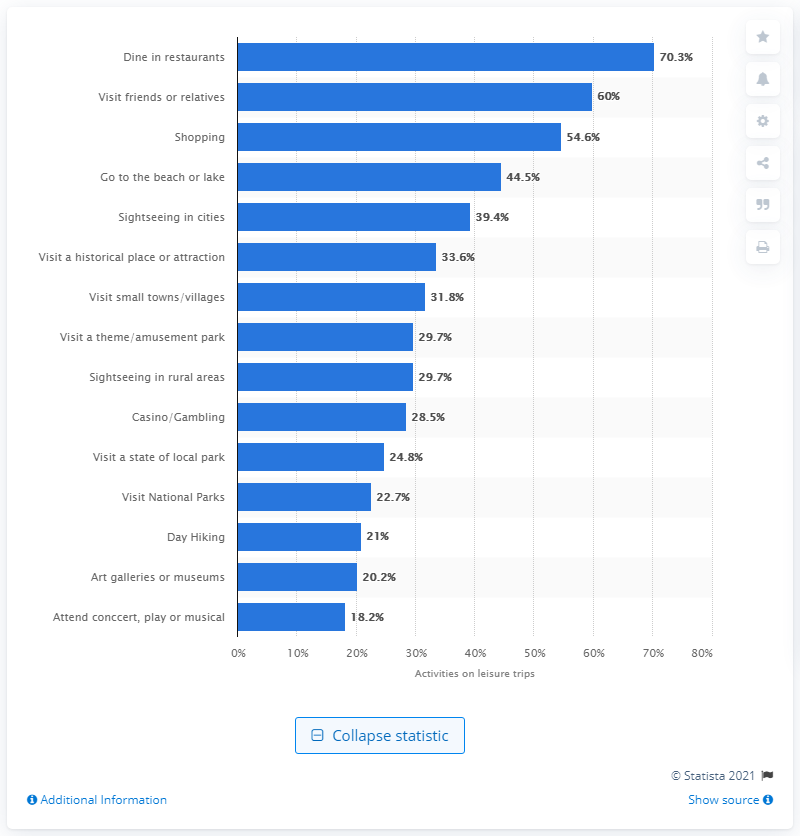What percentage of leisure trip travellers had done dining in a restaurant?
 70.3 